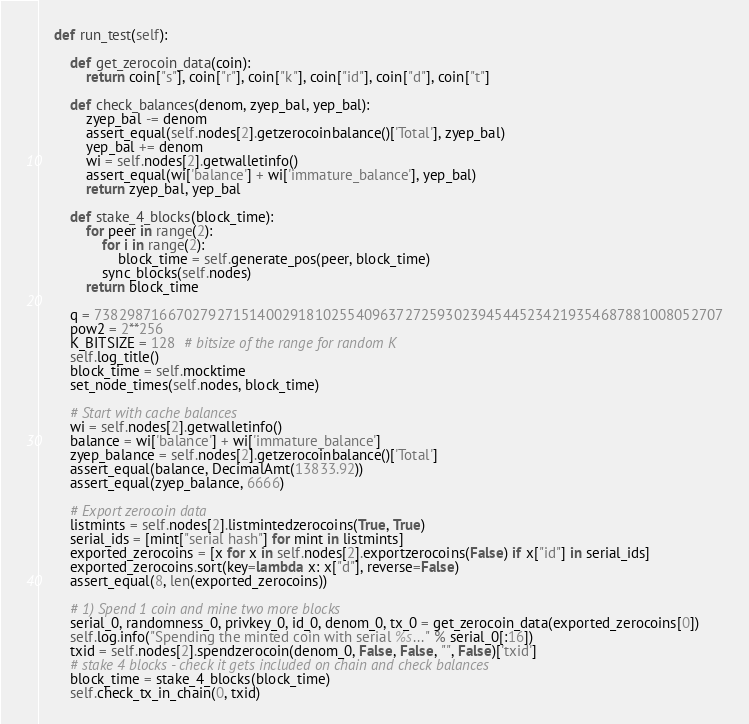<code> <loc_0><loc_0><loc_500><loc_500><_Python_>    def run_test(self):

        def get_zerocoin_data(coin):
            return coin["s"], coin["r"], coin["k"], coin["id"], coin["d"], coin["t"]

        def check_balances(denom, zyep_bal, yep_bal):
            zyep_bal -= denom
            assert_equal(self.nodes[2].getzerocoinbalance()['Total'], zyep_bal)
            yep_bal += denom
            wi = self.nodes[2].getwalletinfo()
            assert_equal(wi['balance'] + wi['immature_balance'], yep_bal)
            return zyep_bal, yep_bal

        def stake_4_blocks(block_time):
            for peer in range(2):
                for i in range(2):
                    block_time = self.generate_pos(peer, block_time)
                sync_blocks(self.nodes)
            return block_time

        q = 73829871667027927151400291810255409637272593023945445234219354687881008052707
        pow2 = 2**256
        K_BITSIZE = 128  # bitsize of the range for random K
        self.log_title()
        block_time = self.mocktime
        set_node_times(self.nodes, block_time)

        # Start with cache balances
        wi = self.nodes[2].getwalletinfo()
        balance = wi['balance'] + wi['immature_balance']
        zyep_balance = self.nodes[2].getzerocoinbalance()['Total']
        assert_equal(balance, DecimalAmt(13833.92))
        assert_equal(zyep_balance, 6666)

        # Export zerocoin data
        listmints = self.nodes[2].listmintedzerocoins(True, True)
        serial_ids = [mint["serial hash"] for mint in listmints]
        exported_zerocoins = [x for x in self.nodes[2].exportzerocoins(False) if x["id"] in serial_ids]
        exported_zerocoins.sort(key=lambda x: x["d"], reverse=False)
        assert_equal(8, len(exported_zerocoins))

        # 1) Spend 1 coin and mine two more blocks
        serial_0, randomness_0, privkey_0, id_0, denom_0, tx_0 = get_zerocoin_data(exported_zerocoins[0])
        self.log.info("Spending the minted coin with serial %s..." % serial_0[:16])
        txid = self.nodes[2].spendzerocoin(denom_0, False, False, "", False)['txid']
        # stake 4 blocks - check it gets included on chain and check balances
        block_time = stake_4_blocks(block_time)
        self.check_tx_in_chain(0, txid)</code> 